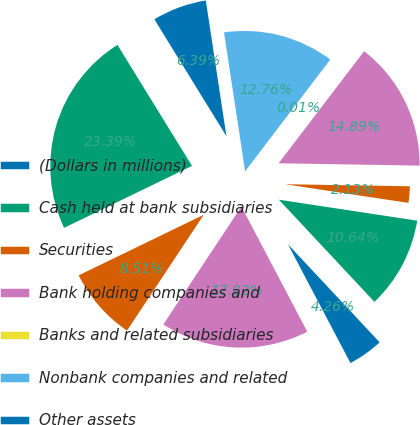Convert chart to OTSL. <chart><loc_0><loc_0><loc_500><loc_500><pie_chart><fcel>(Dollars in millions)<fcel>Cash held at bank subsidiaries<fcel>Securities<fcel>Bank holding companies and<fcel>Banks and related subsidiaries<fcel>Nonbank companies and related<fcel>Other assets<fcel>Total assets (2)<fcel>Accrued expenses and other<fcel>Long-term debt<nl><fcel>4.26%<fcel>10.64%<fcel>2.13%<fcel>14.89%<fcel>0.01%<fcel>12.76%<fcel>6.39%<fcel>23.39%<fcel>8.51%<fcel>17.02%<nl></chart> 